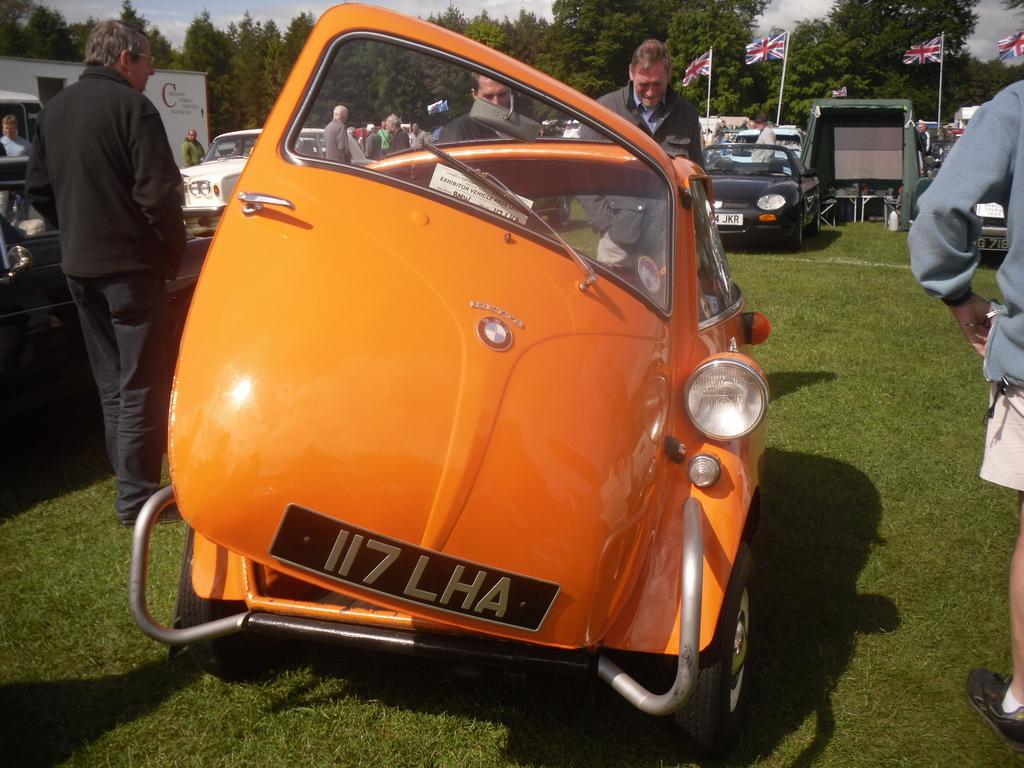In one or two sentences, can you explain what this image depicts? These persons are standing and we can see vehicles on the grass. Background we can see people, flags with sticks, trees and sky. 